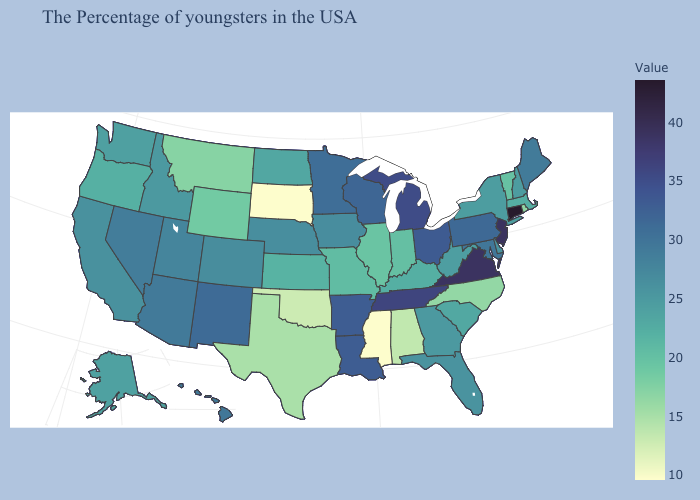Does New Mexico have the highest value in the West?
Write a very short answer. Yes. Which states have the lowest value in the USA?
Give a very brief answer. Mississippi, South Dakota. Does Illinois have the lowest value in the USA?
Keep it brief. No. Which states hav the highest value in the South?
Keep it brief. Virginia. Which states have the lowest value in the USA?
Be succinct. Mississippi, South Dakota. 